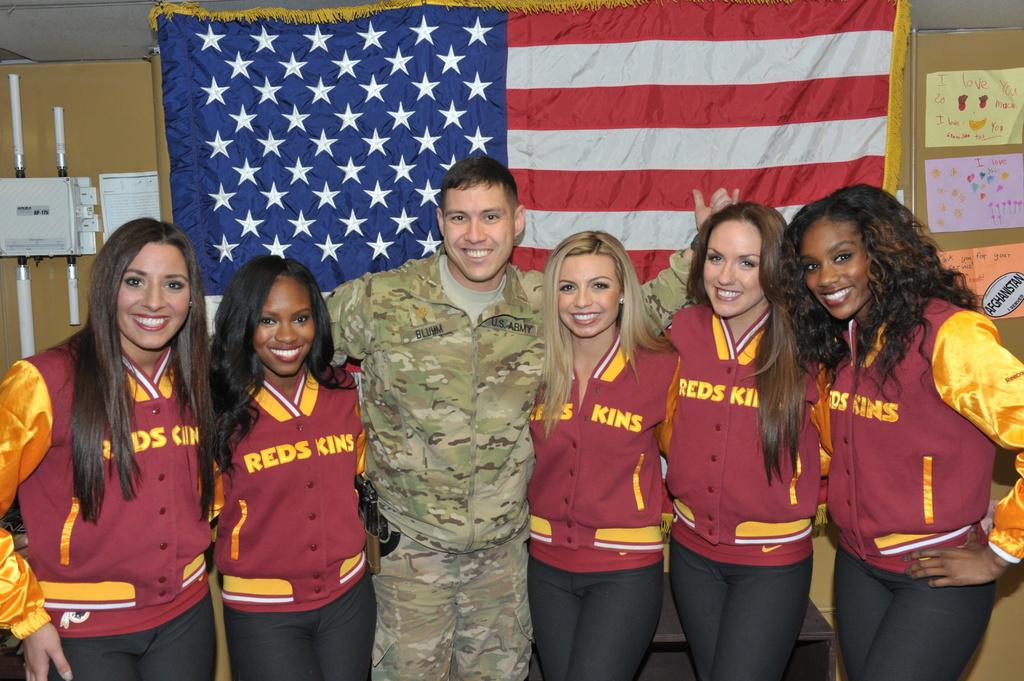<image>
Present a compact description of the photo's key features. A soldier poses with a group of women wearing Redskins jackets 